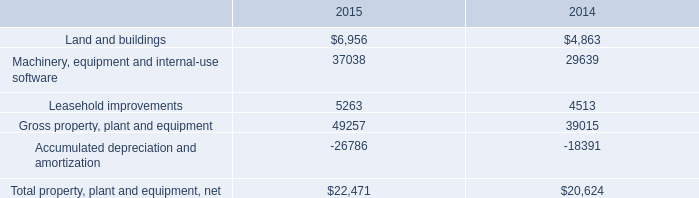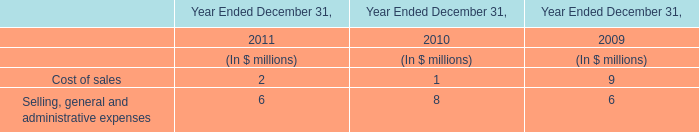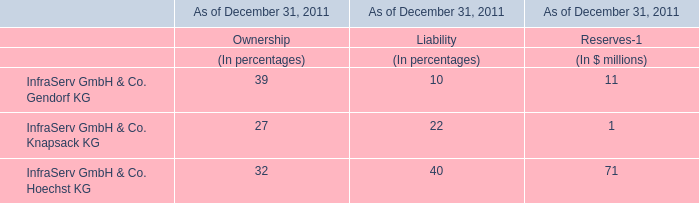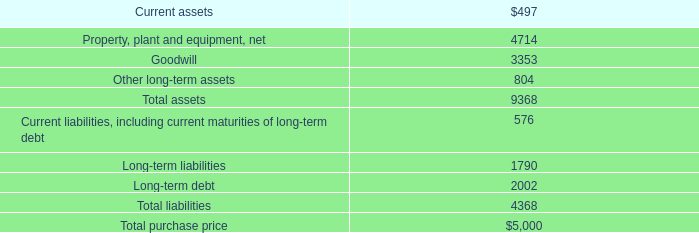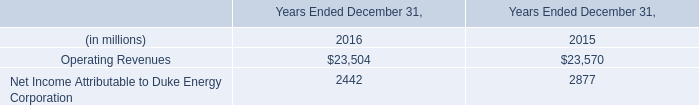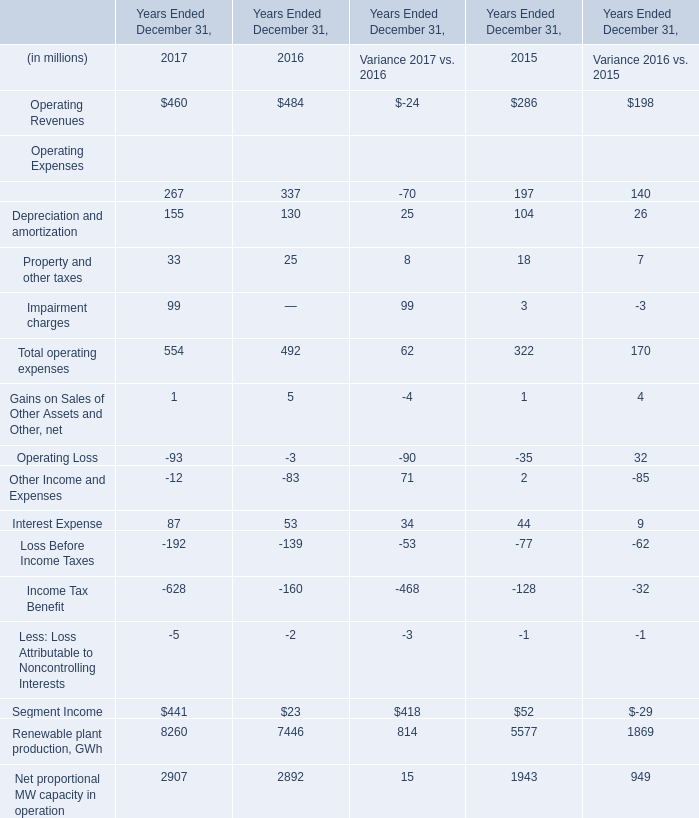what is the percentage change in total property plant and equipment net from 2014 to 2015? 
Computations: ((22471 - 20624) / 20624)
Answer: 0.08956. 